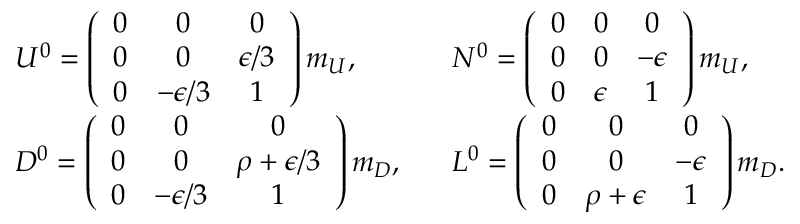Convert formula to latex. <formula><loc_0><loc_0><loc_500><loc_500>\begin{array} { l l } { { U ^ { 0 } = \left ( \begin{array} { c c c } { 0 } & { 0 } & { 0 } \\ { 0 } & { 0 } & { \epsilon / 3 } \\ { 0 } & { - \epsilon / 3 } & { 1 } \end{array} \right ) m _ { U } , } } & { { \, N ^ { 0 } = \left ( \begin{array} { c c c } { 0 } & { 0 } & { 0 } \\ { 0 } & { 0 } & { - \epsilon } \\ { 0 } & { \epsilon } & { 1 } \end{array} \right ) m _ { U } , } } \\ { { D ^ { 0 } = \left ( \begin{array} { c c c } { 0 } & { 0 } & { 0 } \\ { 0 } & { 0 } & { \rho + \epsilon / 3 } \\ { 0 } & { - \epsilon / 3 } & { 1 } \end{array} \right ) m _ { D } , } } & { { \, L ^ { 0 } = \left ( \begin{array} { c c c } { 0 } & { 0 } & { 0 } \\ { 0 } & { 0 } & { - \epsilon } \\ { 0 } & { \rho + \epsilon } & { 1 } \end{array} \right ) m _ { D } . } } \end{array}</formula> 